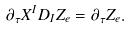<formula> <loc_0><loc_0><loc_500><loc_500>\partial _ { \tau } X ^ { I } D _ { I } Z _ { e } = \partial _ { \tau } Z _ { e } .</formula> 